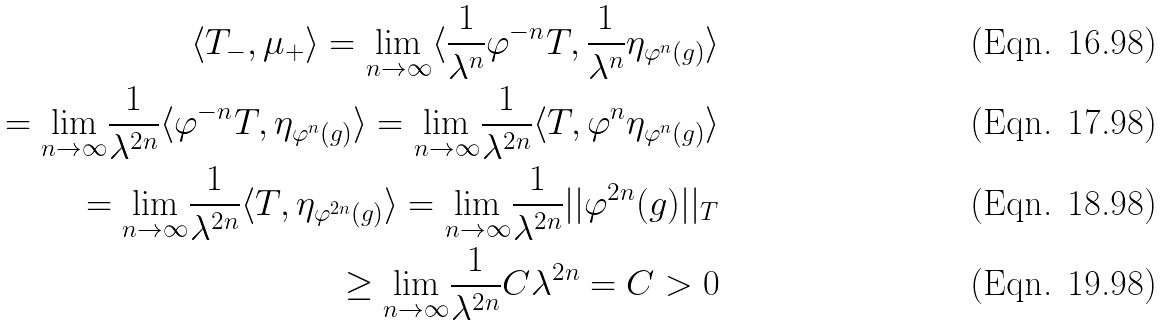Convert formula to latex. <formula><loc_0><loc_0><loc_500><loc_500>\langle T _ { - } , \mu _ { + } \rangle = \underset { n \to \infty } { \lim } \langle \frac { 1 } { \lambda ^ { n } } \varphi ^ { - n } T , \frac { 1 } { \lambda ^ { n } } \eta _ { \varphi ^ { n } ( g ) } \rangle \\ = \underset { n \to \infty } { \lim } \frac { 1 } { \lambda ^ { 2 n } } \langle \varphi ^ { - n } T , \eta _ { \varphi ^ { n } ( g ) } \rangle = \underset { n \to \infty } { \lim } \frac { 1 } { \lambda ^ { 2 n } } \langle T , \varphi ^ { n } \eta _ { \varphi ^ { n } ( g ) } \rangle \\ = \underset { n \to \infty } { \lim } \frac { 1 } { \lambda ^ { 2 n } } \langle T , \eta _ { \varphi ^ { 2 n } ( g ) } \rangle = \underset { n \to \infty } { \lim } \frac { 1 } { \lambda ^ { 2 n } } | | \varphi ^ { 2 n } ( g ) | | _ { T } \\ \geq \underset { n \to \infty } { \lim } \frac { 1 } { \lambda ^ { 2 n } } C \lambda ^ { 2 n } = C > 0</formula> 